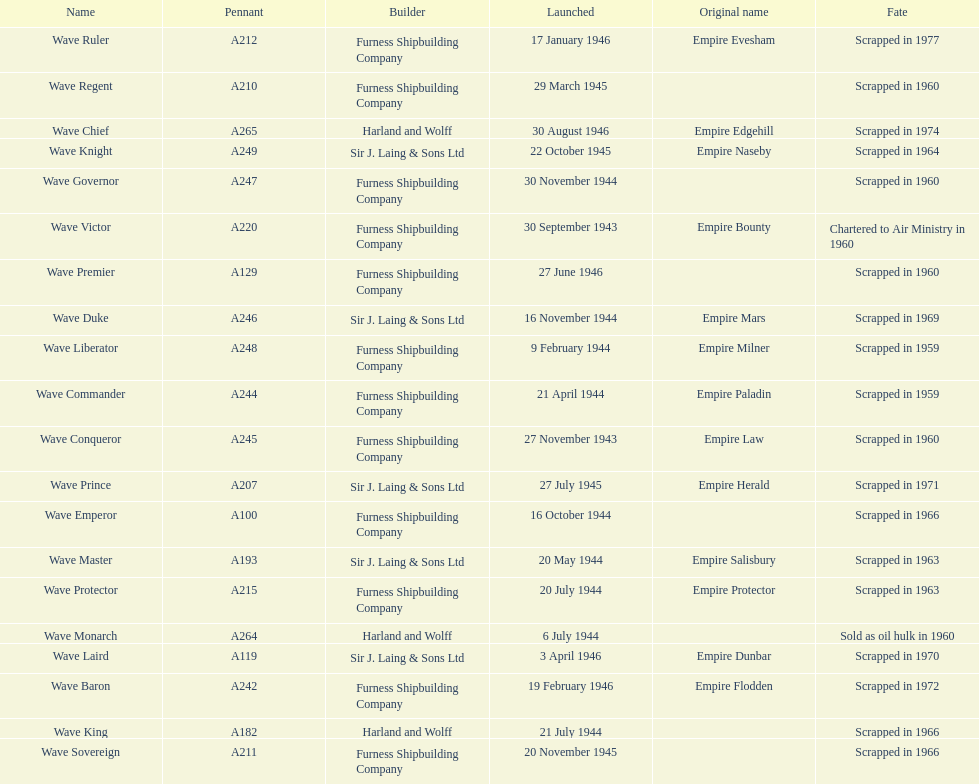Name a builder with "and" in the name. Harland and Wolff. 